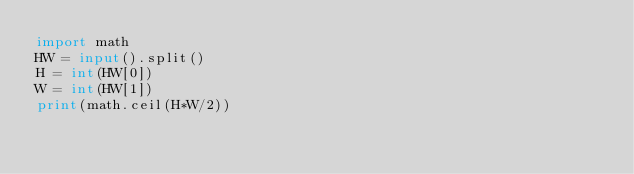<code> <loc_0><loc_0><loc_500><loc_500><_Python_>import math
HW = input().split()
H = int(HW[0])
W = int(HW[1])
print(math.ceil(H*W/2))</code> 